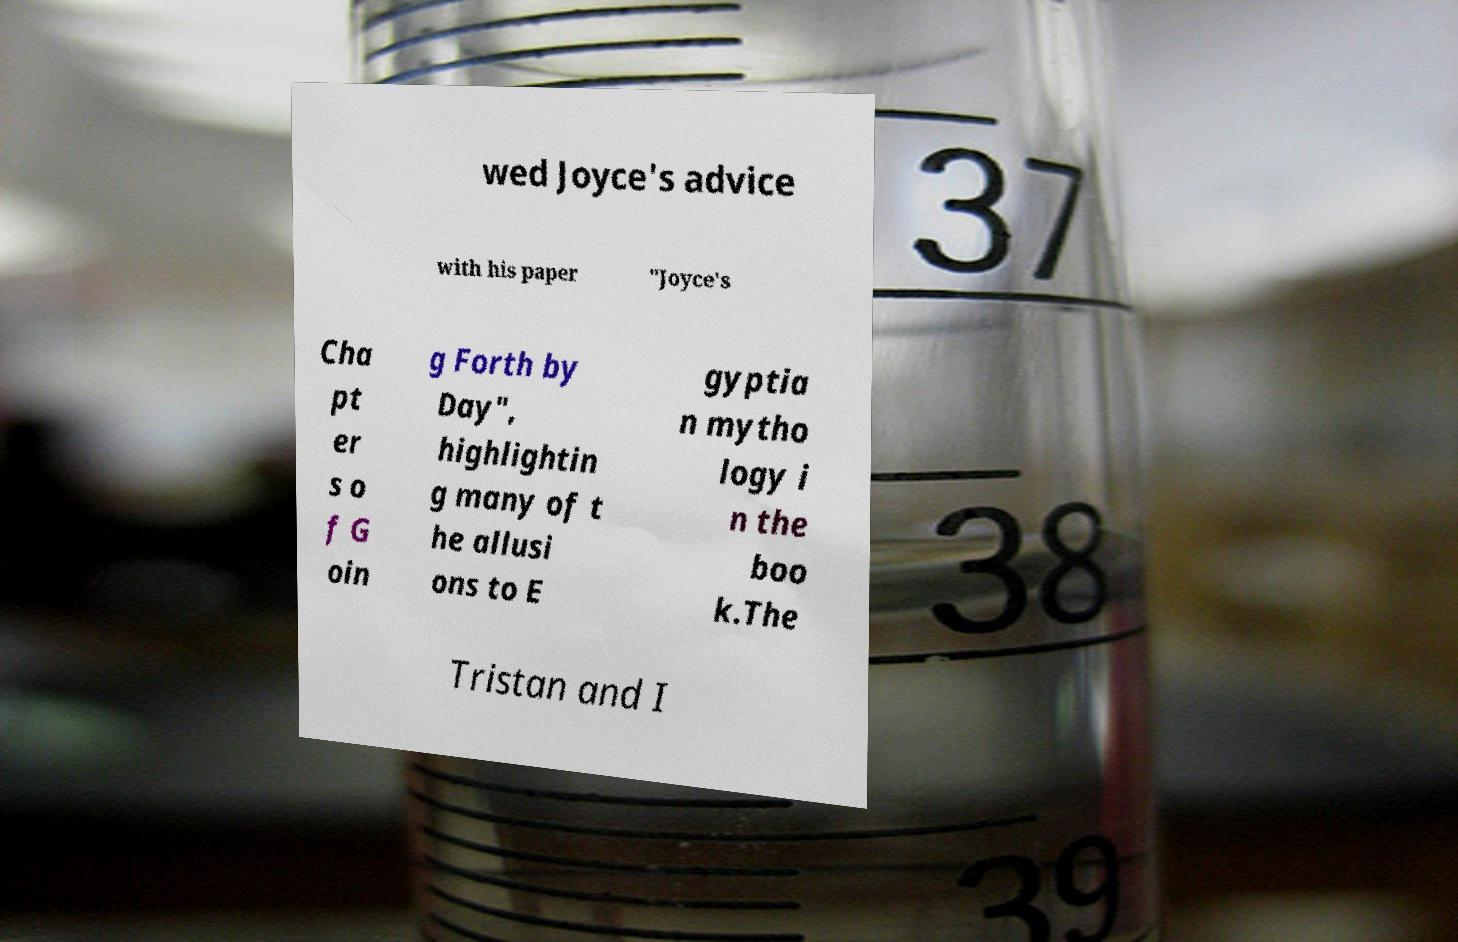Could you assist in decoding the text presented in this image and type it out clearly? wed Joyce's advice with his paper "Joyce's Cha pt er s o f G oin g Forth by Day", highlightin g many of t he allusi ons to E gyptia n mytho logy i n the boo k.The Tristan and I 